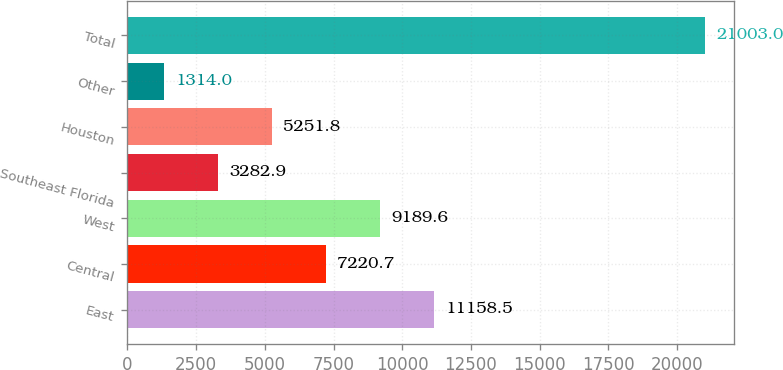<chart> <loc_0><loc_0><loc_500><loc_500><bar_chart><fcel>East<fcel>Central<fcel>West<fcel>Southeast Florida<fcel>Houston<fcel>Other<fcel>Total<nl><fcel>11158.5<fcel>7220.7<fcel>9189.6<fcel>3282.9<fcel>5251.8<fcel>1314<fcel>21003<nl></chart> 